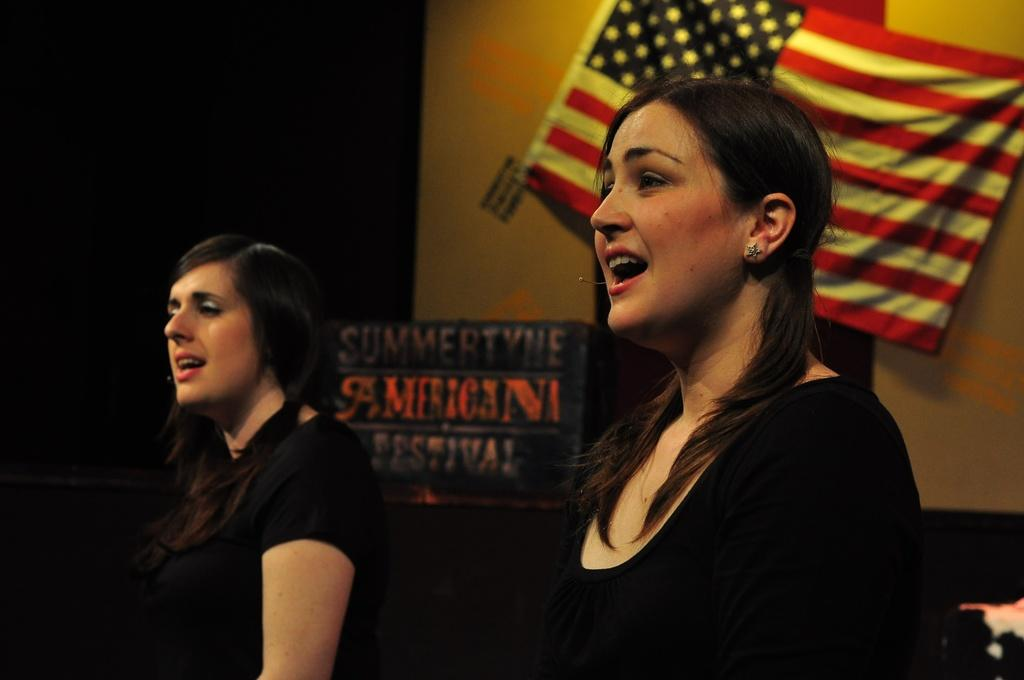What can be seen on the persons in the image? The persons in the image are wearing clothes. What is on the wall in the image? There is a flag on the wall in the image. What is located in the middle of the image? There is a board in the middle of the image. Can you tell me how many airplanes are flying in the image? There are no airplanes visible in the image. What type of patch is sewn onto the clothes of the persons in the image? There is no patch mentioned or visible on the clothes of the persons in the image. 